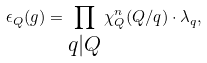<formula> <loc_0><loc_0><loc_500><loc_500>\epsilon _ { Q } ( g ) = \prod _ { \substack { q | Q \\ } } \chi ^ { n } _ { Q } ( Q / q ) \cdot \lambda _ { q } ,</formula> 